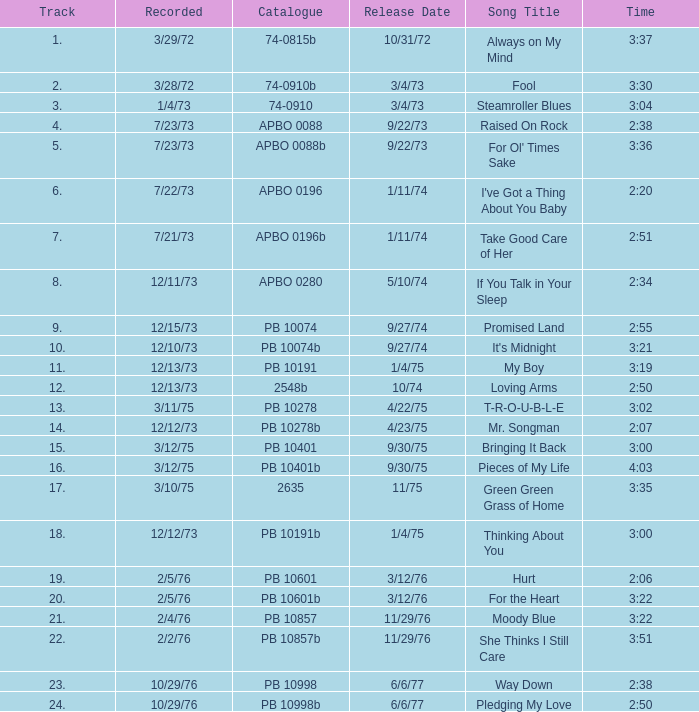Tell me the release date record on 10/29/76 and a time on 2:50 6/6/77. 